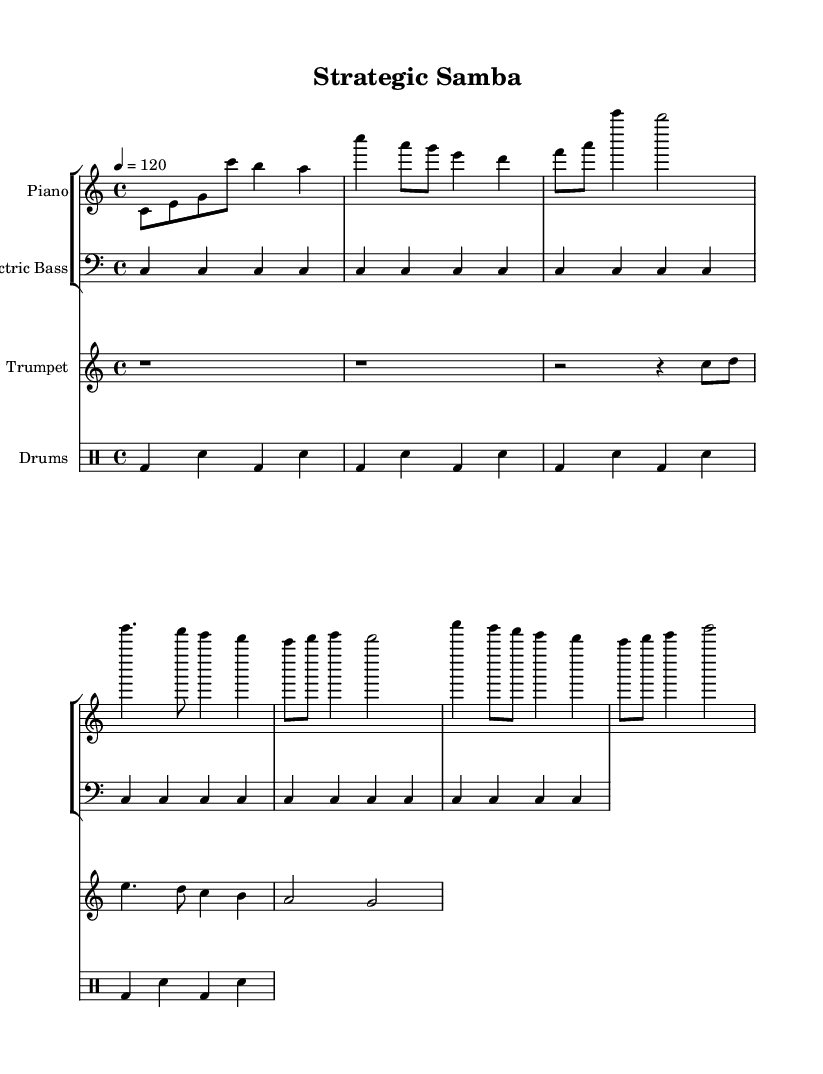What is the key signature of this music? The key signature is C major, which has no sharps or flats.
Answer: C major What is the time signature of the piece? The time signature is indicated at the beginning of the score as 4/4, meaning there are four beats in each measure, and the quarter note receives one beat.
Answer: 4/4 What is the tempo marking for this music? The tempo is marked as a quarter note equals 120 beats per minute, indicated at the beginning of the score.
Answer: 120 How many bars are there in the piano part? By counting the measures in the piano voice, there are a total of 6 bars in the piano part.
Answer: 6 Which instrument plays the rhythm in this arrangement? The drums are responsible for accentuating the rhythm, as indicated by the drummode lines in the score.
Answer: Drums What is the highest pitch in the trumpet part? The highest note in the trumpet part is a g, which is indicated in the second measure, making it the highest pitch in this section.
Answer: g What style of music does "Strategic Samba" represent? The title suggests it draws from samba, a leading genre in Latin music, which typically involves rhythmic and lively elements present in the score.
Answer: Samba 